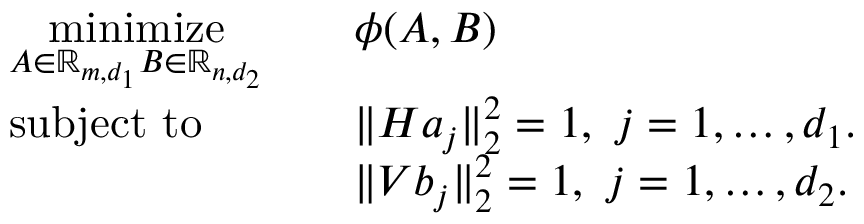Convert formula to latex. <formula><loc_0><loc_0><loc_500><loc_500>\begin{array} { r l r l } & { \underset { A \in \mathbb { R } _ { m , d _ { 1 } } B \in \mathbb { R } _ { n , d _ { 2 } } } { \min i m i z e } } & & { \phi ( { A } , B ) } \\ & { s u b j e c t t o } & & { \| H a _ { j } \| _ { 2 } ^ { 2 } = 1 , \ j = 1 , \dots , d _ { 1 } . } \\ & & { \| V b _ { j } \| _ { 2 } ^ { 2 } = 1 , \ j = 1 , \dots , d _ { 2 } . } \end{array}</formula> 